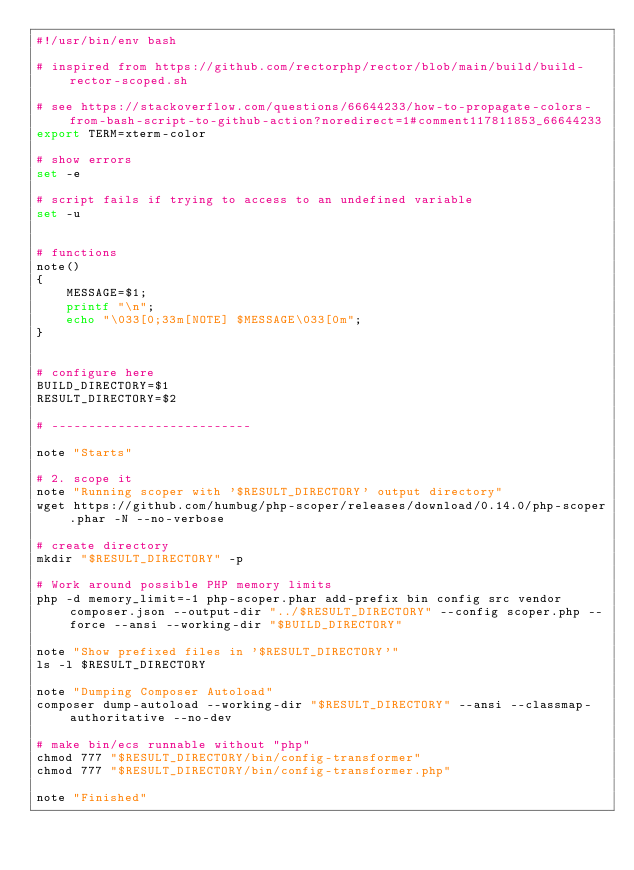<code> <loc_0><loc_0><loc_500><loc_500><_Bash_>#!/usr/bin/env bash

# inspired from https://github.com/rectorphp/rector/blob/main/build/build-rector-scoped.sh

# see https://stackoverflow.com/questions/66644233/how-to-propagate-colors-from-bash-script-to-github-action?noredirect=1#comment117811853_66644233
export TERM=xterm-color

# show errors
set -e

# script fails if trying to access to an undefined variable
set -u


# functions
note()
{
    MESSAGE=$1;
    printf "\n";
    echo "\033[0;33m[NOTE] $MESSAGE\033[0m";
}


# configure here
BUILD_DIRECTORY=$1
RESULT_DIRECTORY=$2

# ---------------------------

note "Starts"

# 2. scope it
note "Running scoper with '$RESULT_DIRECTORY' output directory"
wget https://github.com/humbug/php-scoper/releases/download/0.14.0/php-scoper.phar -N --no-verbose

# create directory
mkdir "$RESULT_DIRECTORY" -p

# Work around possible PHP memory limits
php -d memory_limit=-1 php-scoper.phar add-prefix bin config src vendor composer.json --output-dir "../$RESULT_DIRECTORY" --config scoper.php --force --ansi --working-dir "$BUILD_DIRECTORY"

note "Show prefixed files in '$RESULT_DIRECTORY'"
ls -l $RESULT_DIRECTORY

note "Dumping Composer Autoload"
composer dump-autoload --working-dir "$RESULT_DIRECTORY" --ansi --classmap-authoritative --no-dev

# make bin/ecs runnable without "php"
chmod 777 "$RESULT_DIRECTORY/bin/config-transformer"
chmod 777 "$RESULT_DIRECTORY/bin/config-transformer.php"

note "Finished"
</code> 